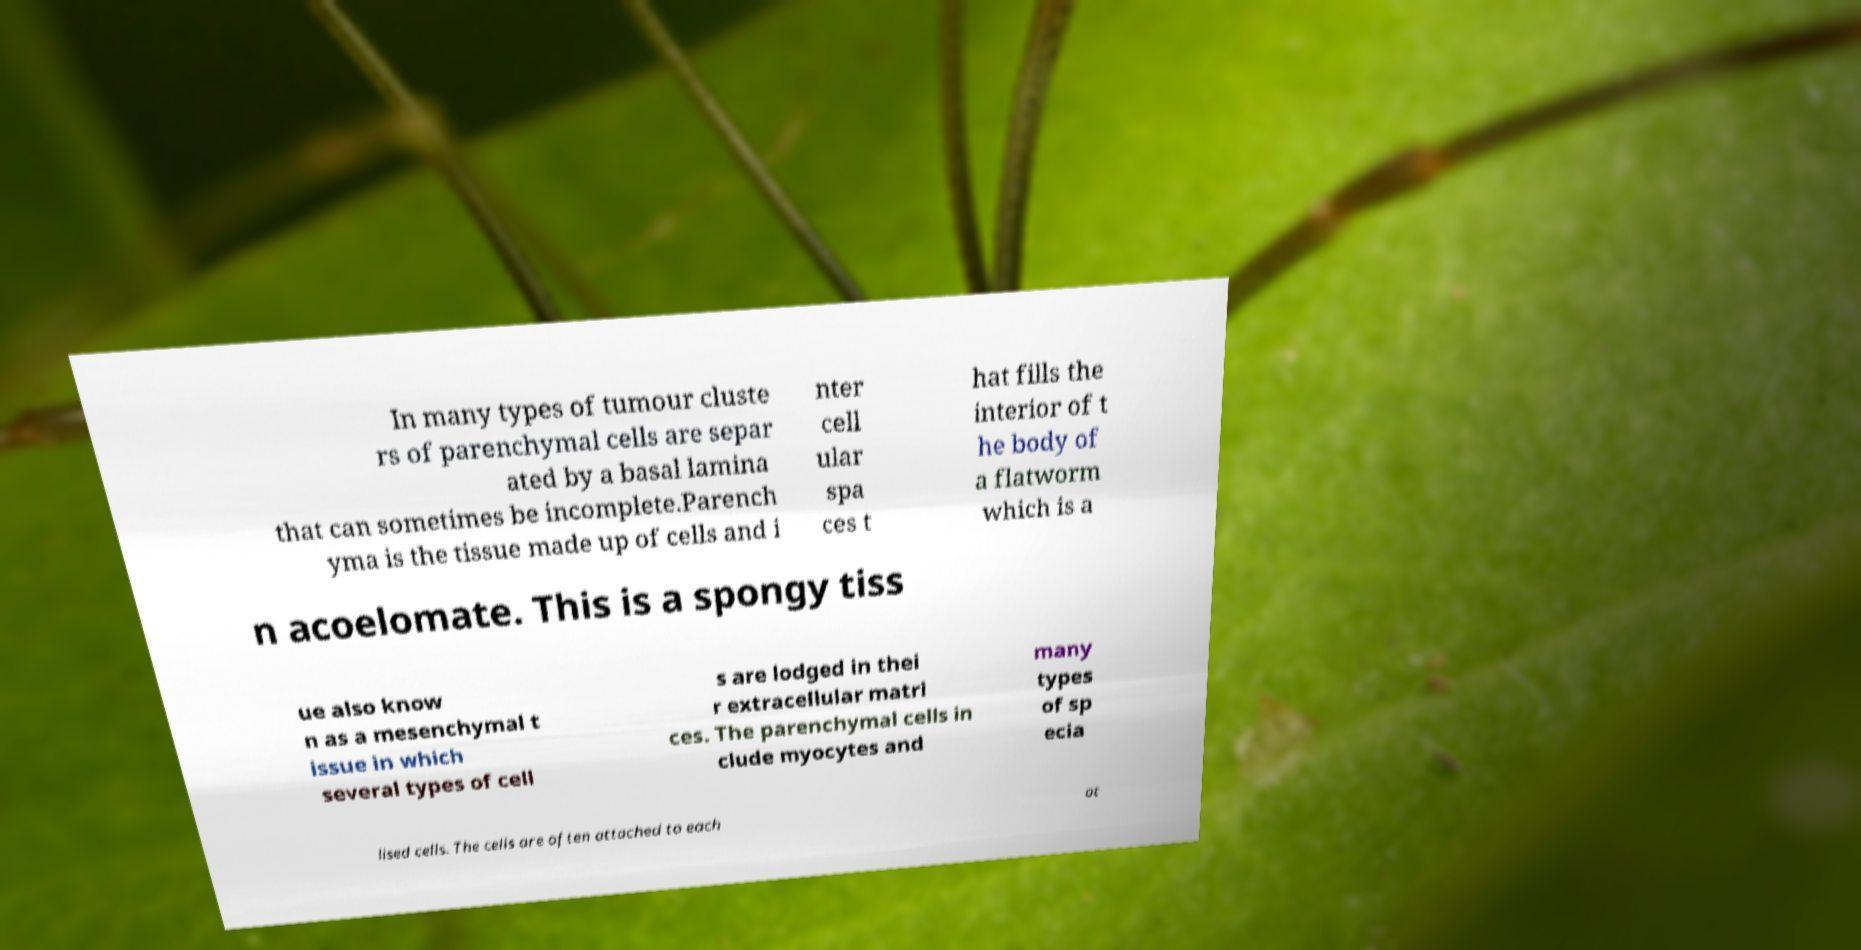Can you read and provide the text displayed in the image?This photo seems to have some interesting text. Can you extract and type it out for me? In many types of tumour cluste rs of parenchymal cells are separ ated by a basal lamina that can sometimes be incomplete.Parench yma is the tissue made up of cells and i nter cell ular spa ces t hat fills the interior of t he body of a flatworm which is a n acoelomate. This is a spongy tiss ue also know n as a mesenchymal t issue in which several types of cell s are lodged in thei r extracellular matri ces. The parenchymal cells in clude myocytes and many types of sp ecia lised cells. The cells are often attached to each ot 